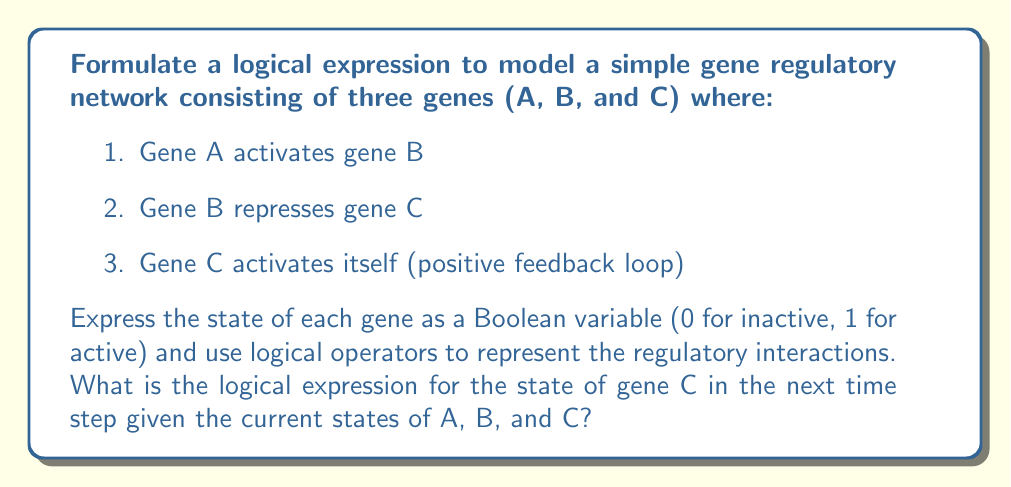Can you solve this math problem? To model this gene regulatory network, we'll use Boolean logic to represent the state of each gene and the interactions between them. Let's break down the process step-by-step:

1. Define variables:
   Let $A_t$, $B_t$, and $C_t$ represent the current state of genes A, B, and C, respectively.
   Let $C_{t+1}$ represent the state of gene C in the next time step.

2. Analyze the regulatory interactions:
   a. Gene A activates gene B: This doesn't directly affect C, so we don't need to include A in our expression for C.
   b. Gene B represses gene C: This means C will be active (1) when B is inactive (0).
   c. Gene C activates itself: C will remain active if it's currently active, regardless of B's state.

3. Translate these interactions into logical operations:
   a. B repressing C can be represented as $\neg B_t$ (NOT B)
   b. C activating itself can be represented as $C_t$
   c. The overall activation of C occurs when either B is not repressing it OR C is already active

4. Combine the logical operations:
   The state of C in the next time step ($C_{t+1}$) will be 1 (active) if either B is not repressing it ($\neg B_t$) OR C is currently active ($C_t$).

5. Express this using the logical OR operator:
   $C_{t+1} = \neg B_t \vee C_t$

This logical expression captures the regulatory interactions affecting gene C in this simple network.
Answer: $C_{t+1} = \neg B_t \vee C_t$ 